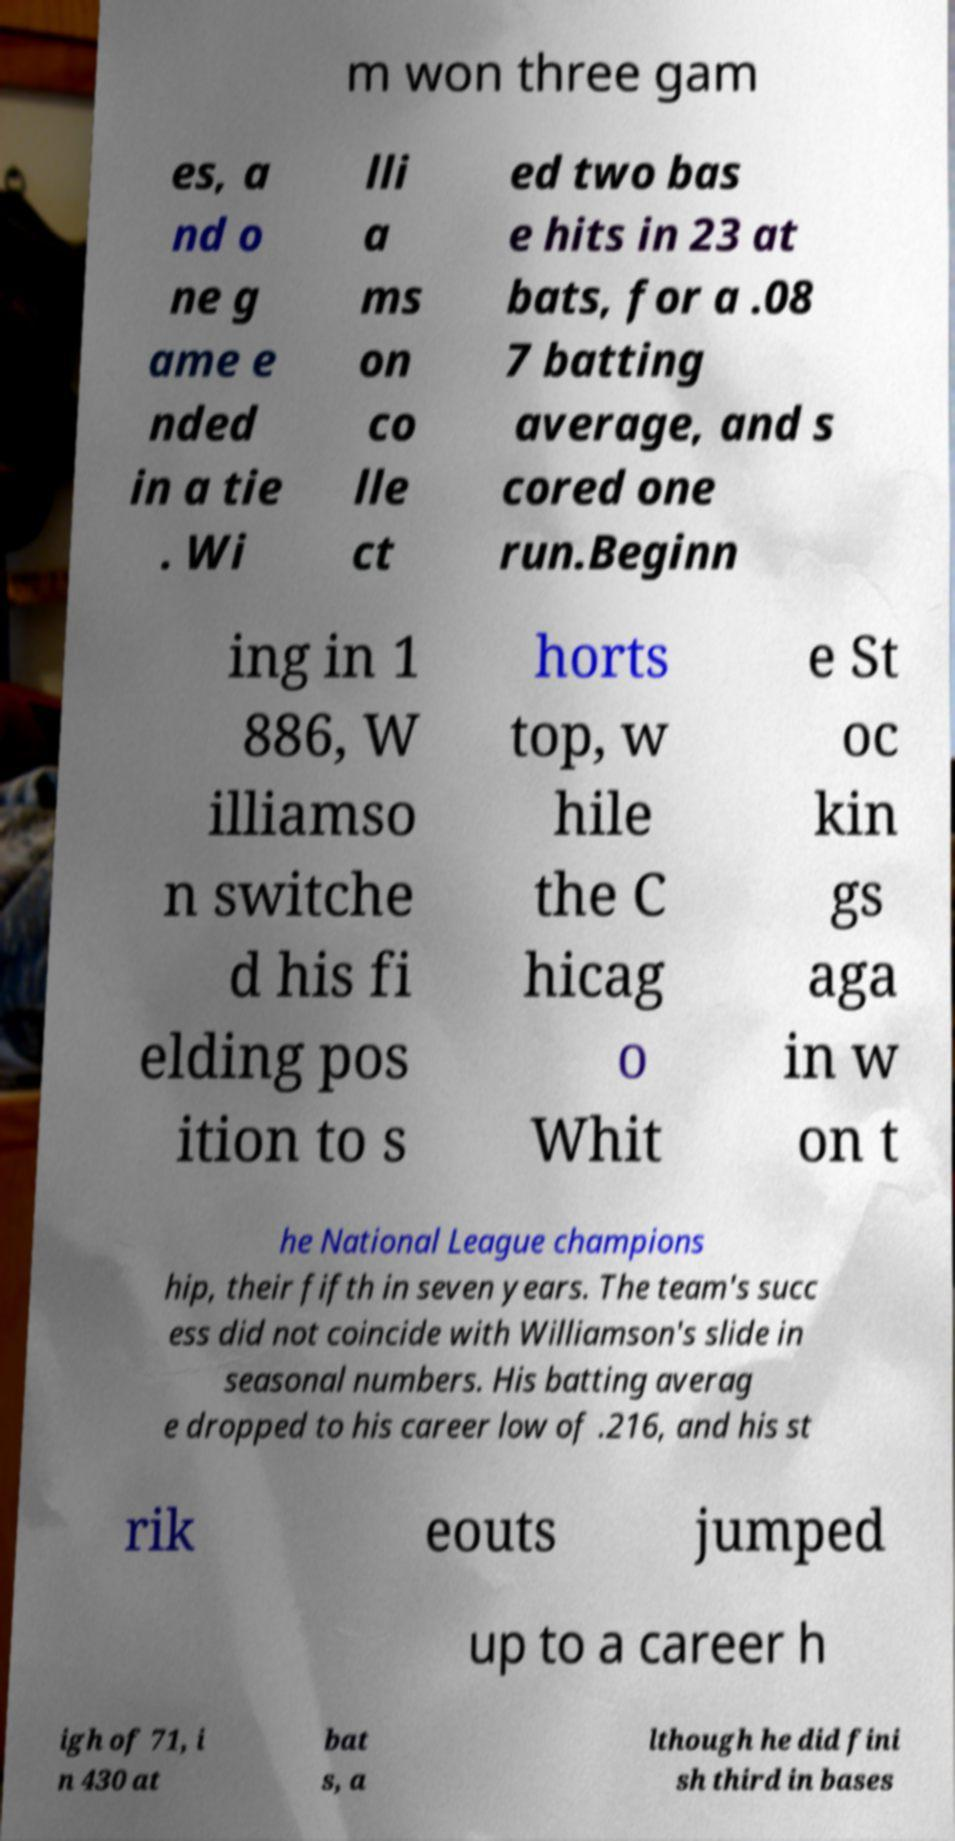I need the written content from this picture converted into text. Can you do that? m won three gam es, a nd o ne g ame e nded in a tie . Wi lli a ms on co lle ct ed two bas e hits in 23 at bats, for a .08 7 batting average, and s cored one run.Beginn ing in 1 886, W illiamso n switche d his fi elding pos ition to s horts top, w hile the C hicag o Whit e St oc kin gs aga in w on t he National League champions hip, their fifth in seven years. The team's succ ess did not coincide with Williamson's slide in seasonal numbers. His batting averag e dropped to his career low of .216, and his st rik eouts jumped up to a career h igh of 71, i n 430 at bat s, a lthough he did fini sh third in bases 